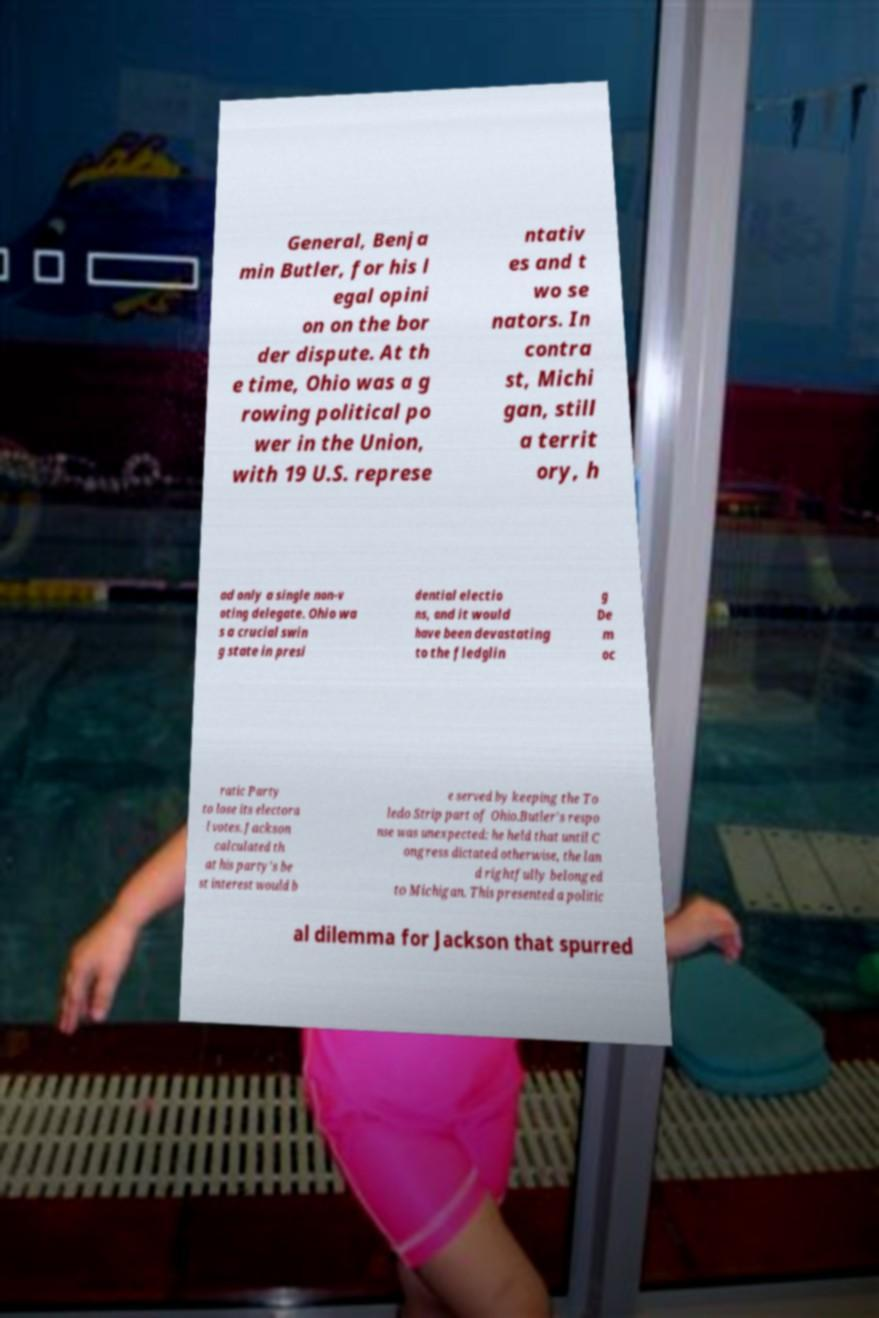Can you read and provide the text displayed in the image?This photo seems to have some interesting text. Can you extract and type it out for me? General, Benja min Butler, for his l egal opini on on the bor der dispute. At th e time, Ohio was a g rowing political po wer in the Union, with 19 U.S. represe ntativ es and t wo se nators. In contra st, Michi gan, still a territ ory, h ad only a single non-v oting delegate. Ohio wa s a crucial swin g state in presi dential electio ns, and it would have been devastating to the fledglin g De m oc ratic Party to lose its electora l votes. Jackson calculated th at his party's be st interest would b e served by keeping the To ledo Strip part of Ohio.Butler's respo nse was unexpected: he held that until C ongress dictated otherwise, the lan d rightfully belonged to Michigan. This presented a politic al dilemma for Jackson that spurred 